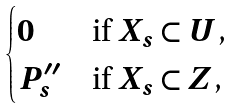<formula> <loc_0><loc_0><loc_500><loc_500>\begin{cases} 0 & \text {if $X_{s} \subset U$,} \\ P ^ { \prime \prime } _ { s } & \text {if $X_{s} \subset Z$,} \end{cases}</formula> 